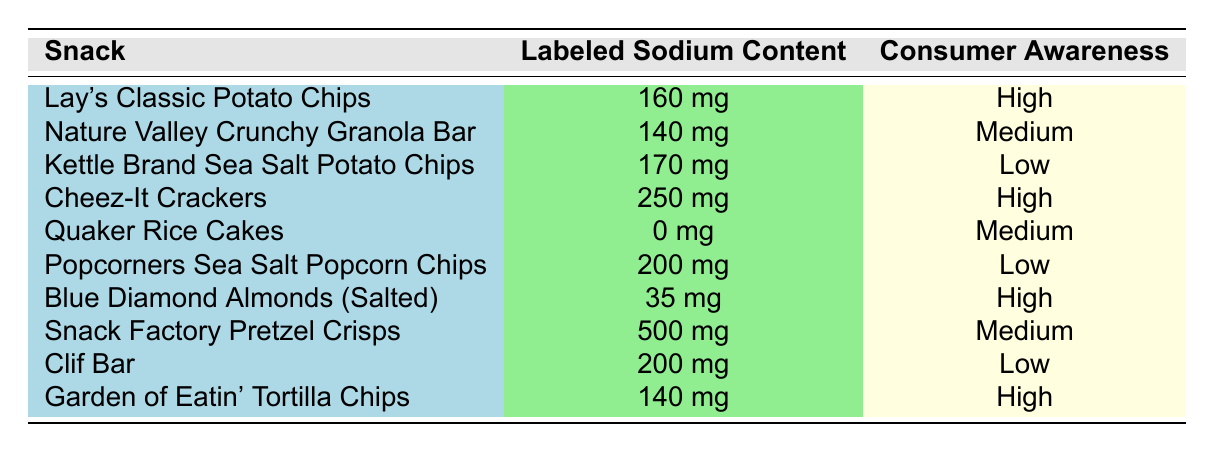What is the labeled sodium content of Lay's Classic Potato Chips? The table shows the entry for Lay's Classic Potato Chips, where the labeled sodium content is listed as 160 mg.
Answer: 160 mg How many snacks have high consumer awareness? By examining the consumer awareness column in the table, the snacks that have high consumer awareness are: Lay's Classic Potato Chips, Cheez-It Crackers, Blue Diamond Almonds (Salted), and Garden of Eatin' Tortilla Chips. There are a total of 4 snacks.
Answer: 4 Is the labeled sodium content of Quaker Rice Cakes greater than that of Popcorners Sea Salt Popcorn Chips? The labeled sodium content for Quaker Rice Cakes is 0 mg, while for Popcorners Sea Salt Popcorn Chips it is 200 mg. Since 0 mg is less than 200 mg, the statement is false.
Answer: No What is the average labeled sodium content for snacks with medium consumer awareness? The snacks with medium consumer awareness are: Nature Valley Crunchy Granola Bar (140 mg), Quaker Rice Cakes (0 mg), and Snack Factory Pretzel Crisps (500 mg). Summing these values gives 640 mg. Dividing by the 3 snacks gives an average of 640 mg / 3 = 213.33 mg.
Answer: 213.33 mg Are there any snacks with both high consumer awareness and sodium content lower than 200 mg? The high consumer awareness snacks are: Lay's Classic Potato Chips (160 mg), Cheez-It Crackers (250 mg), Blue Diamond Almonds (Salted) (35 mg), and Garden of Eatin' Tortilla Chips (140 mg). Among these, Lay's Classic Potato Chips and Blue Diamond Almonds (Salted) have sodium contents lower than 200 mg. Therefore, there are snacks that fit this criterion, so the answer is yes.
Answer: Yes What is the difference in labeled sodium content between the snack with the highest and the lowest sodium content? The snack with the highest labeled sodium content is Snack Factory Pretzel Crisps with 500 mg, and the lowest is Blue Diamond Almonds (Salted) with 35 mg. The difference is calculated as 500 mg - 35 mg = 465 mg.
Answer: 465 mg 